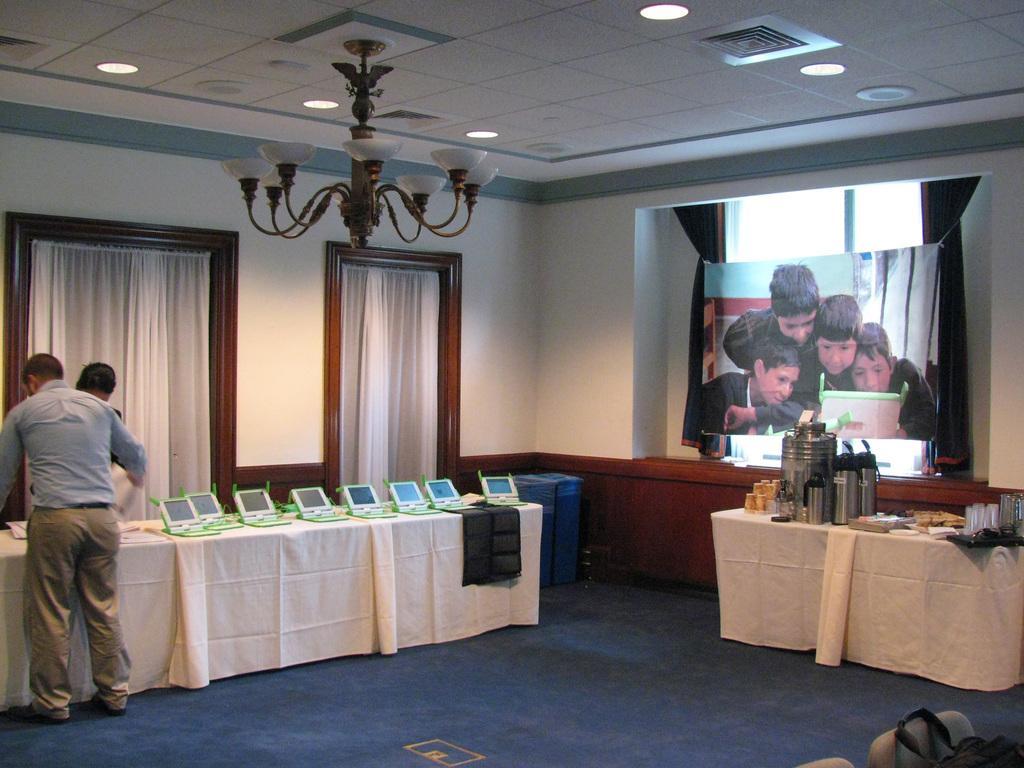Describe this image in one or two sentences. In this image,we can see on right side there is a photo banner and brown color curtain. There is a table and few items are placed on it. On left side, 2 peoples are standing near the table. Few laptops are placed on the table. There is a black color cloth in the middle. At the background, we can see white color curtains and wooden frame. The roof, white color roof and chandelier is hanging and lights we can see. And the bottom ,there is a blue color floor. the right side corner, we can see bag and cream color chair. 